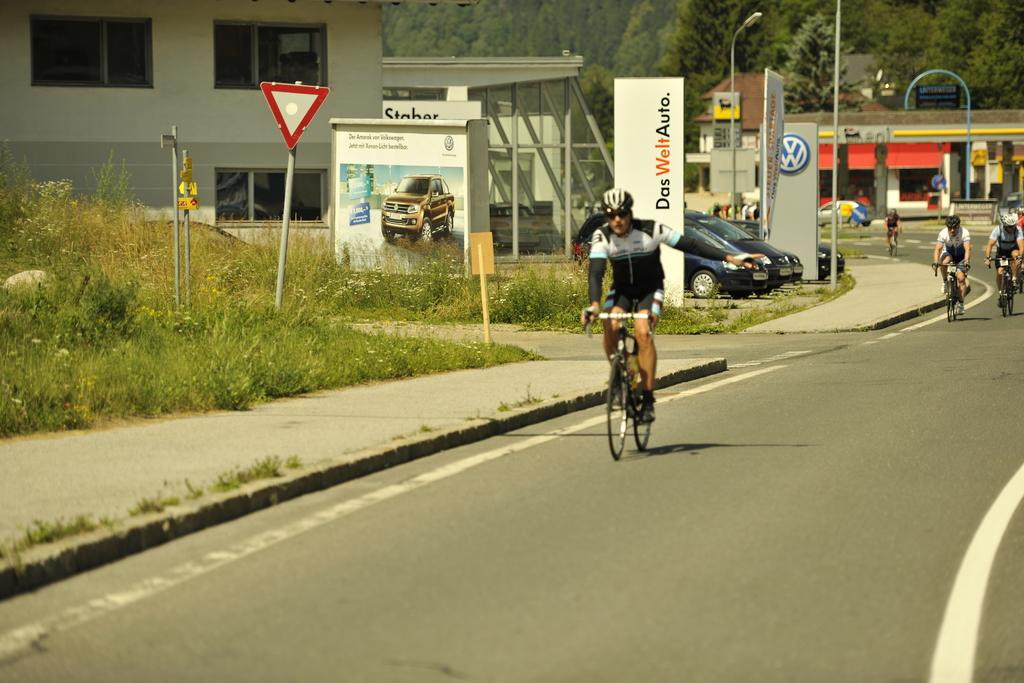What are the people in the image doing? The people in the image are riding bicycles on the road. What else can be seen in the image besides the people on bicycles? There are plants, boards, buildings, parked vehicles, and trees in the background of the image. Can you see the daughter of the person riding the bicycle in the image? There is no mention of a daughter or any specific person in the image, so it cannot be determined if a daughter is present. 